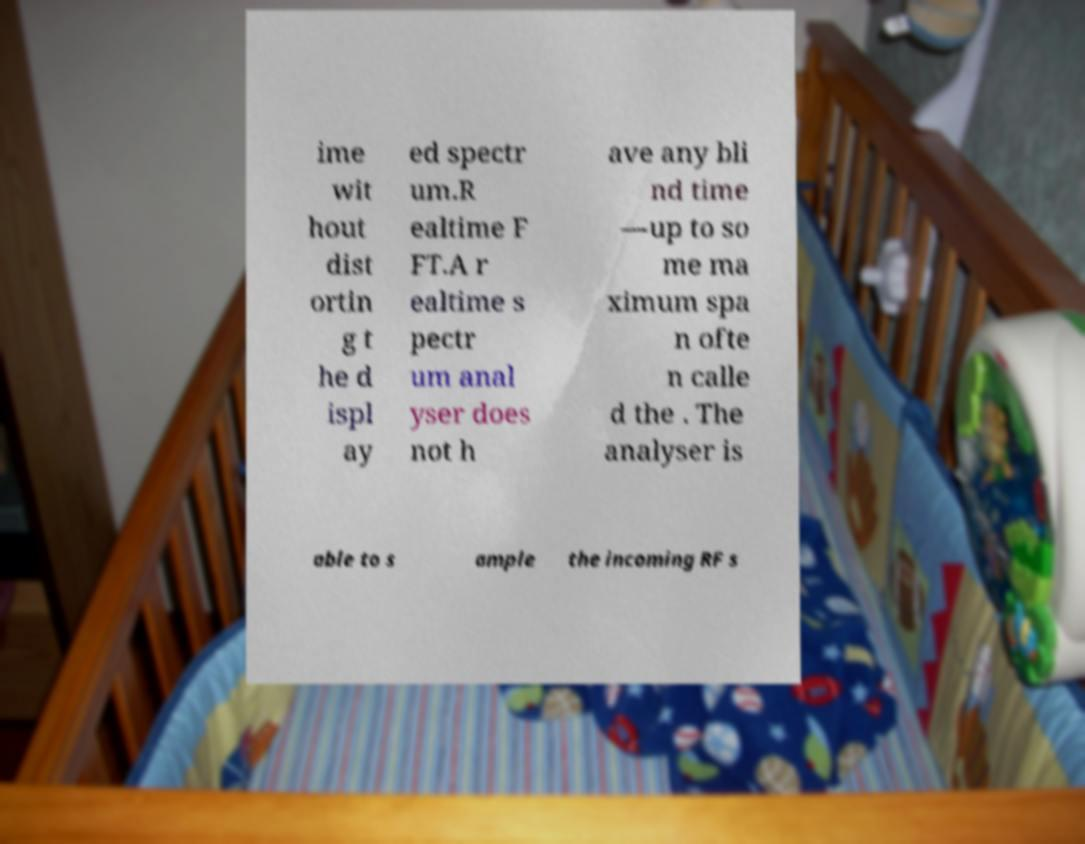Please read and relay the text visible in this image. What does it say? ime wit hout dist ortin g t he d ispl ay ed spectr um.R ealtime F FT.A r ealtime s pectr um anal yser does not h ave any bli nd time —up to so me ma ximum spa n ofte n calle d the . The analyser is able to s ample the incoming RF s 